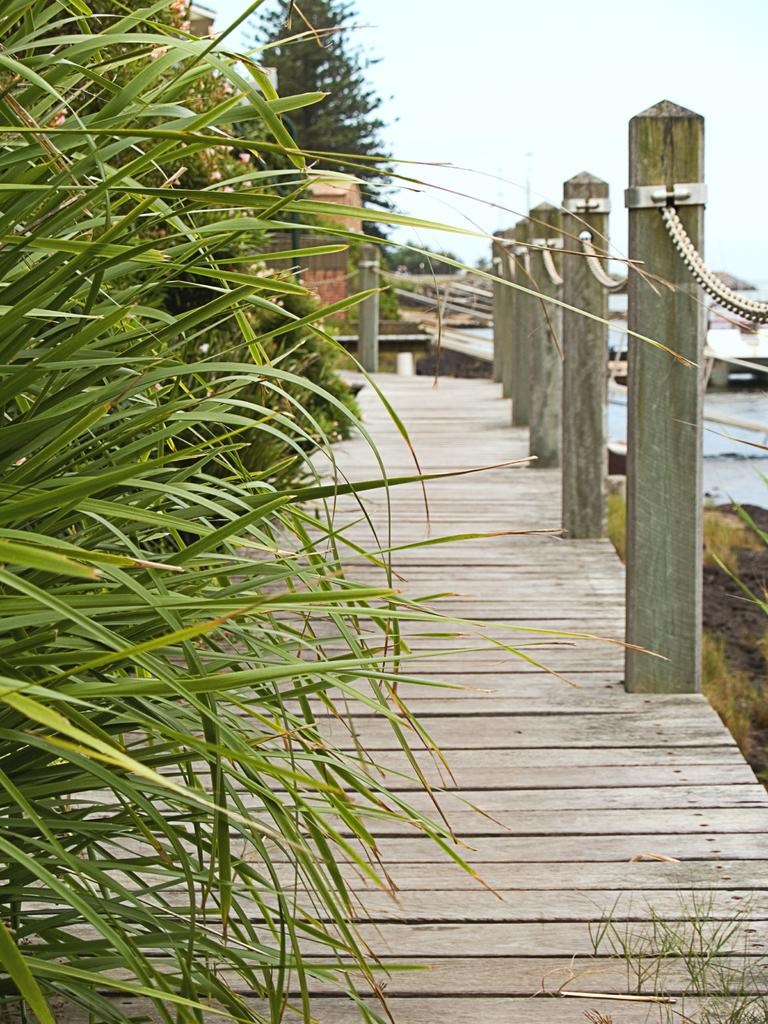What can be seen on the bridge in the image? There are plants on the bridge on the left side of the image. What structures are present in the image? There are poles and a chain-like fence in the image. What is visible in the background of the image? There is a tree, grass, a boat on the water, and the sky visible in the background of the image. What type of insect can be seen drinking soda on the boat in the image? There are no insects or soda present in the image. Are there any bears visible in the image? No, there are no bears present in the image. 